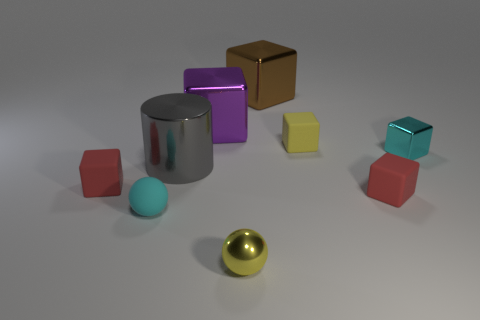There is a purple object that is to the left of the tiny red rubber cube that is right of the large brown shiny object that is right of the small yellow shiny object; what is it made of?
Make the answer very short. Metal. What is the size of the cube that is in front of the small yellow cube and on the left side of the large brown shiny thing?
Provide a short and direct response. Small. Does the yellow matte thing have the same shape as the big purple shiny thing?
Provide a short and direct response. Yes. What shape is the yellow object that is the same material as the purple block?
Provide a succinct answer. Sphere. What number of tiny things are red things or gray things?
Ensure brevity in your answer.  2. There is a big object that is on the left side of the big purple metal cube; are there any yellow shiny objects that are behind it?
Your answer should be very brief. No. Are any large red cylinders visible?
Offer a terse response. No. There is a sphere that is behind the yellow thing that is in front of the shiny cylinder; what color is it?
Give a very brief answer. Cyan. There is a tiny yellow object that is the same shape as the purple object; what is its material?
Give a very brief answer. Rubber. How many metallic spheres are the same size as the cyan rubber ball?
Your answer should be very brief. 1. 